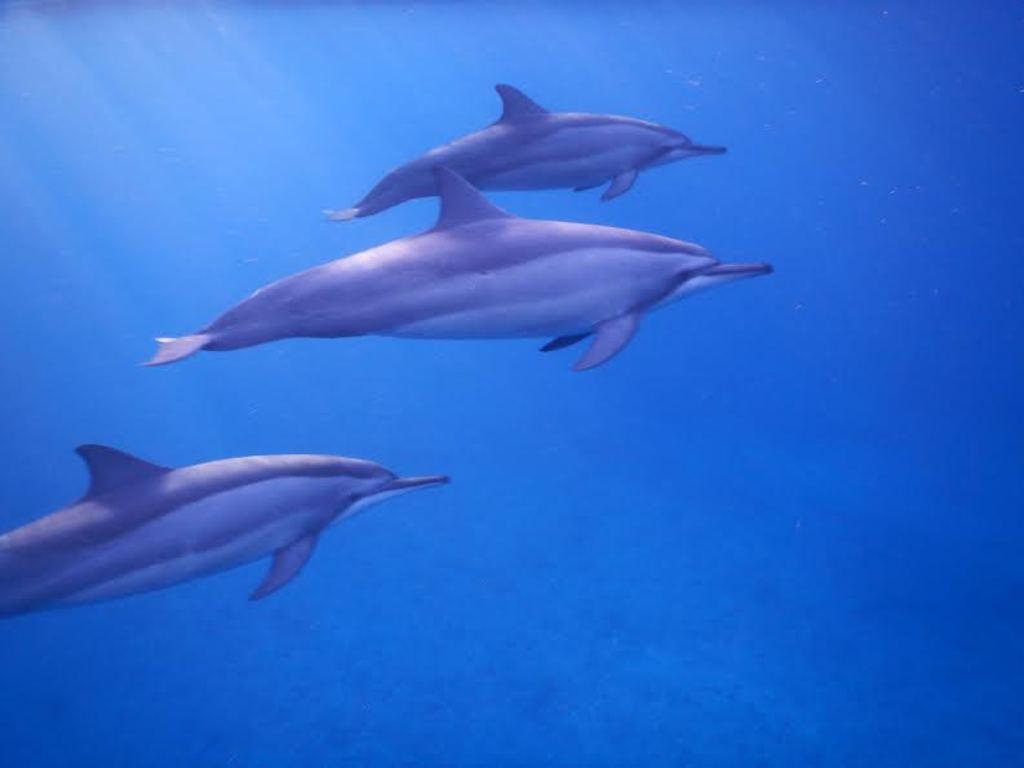Please provide a concise description of this image. This picture is taken in the water. In this image, in the middle, we can see two sharks, which are in the water. On the left side, we can also see another shark. In the background, we can see blue color. 